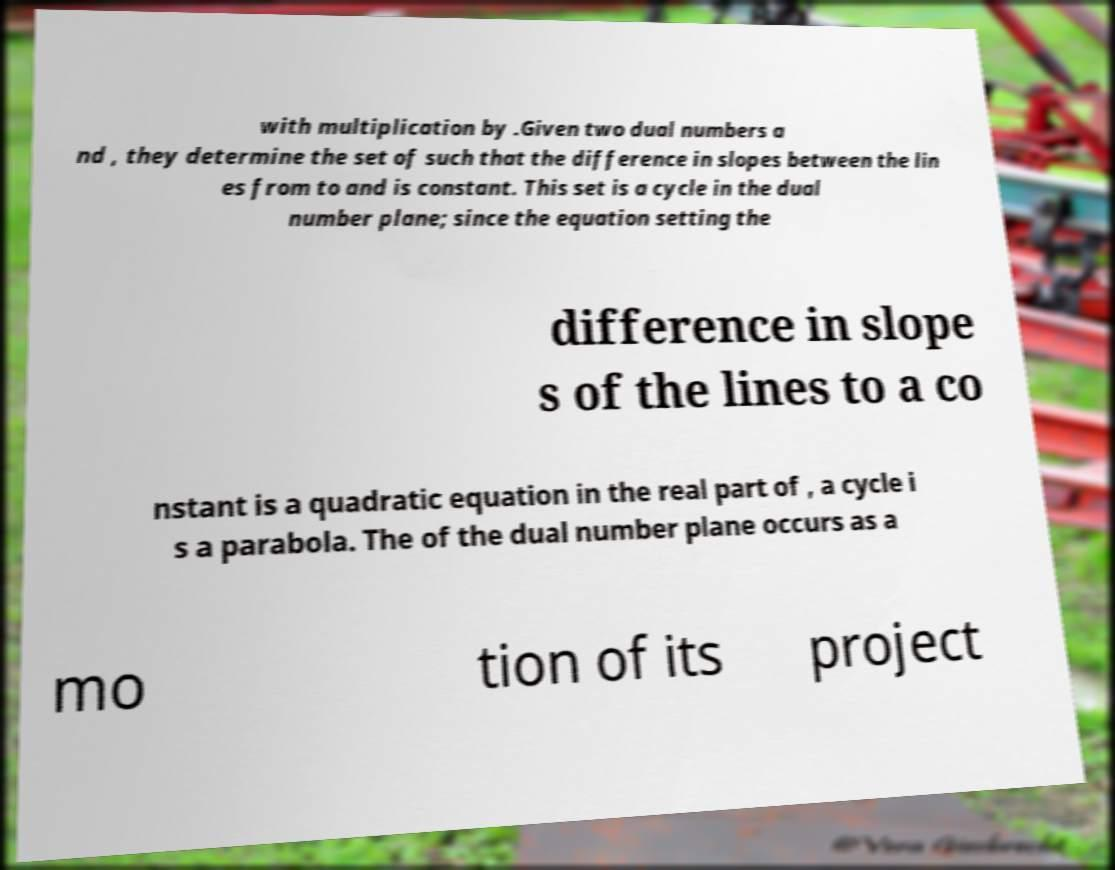I need the written content from this picture converted into text. Can you do that? with multiplication by .Given two dual numbers a nd , they determine the set of such that the difference in slopes between the lin es from to and is constant. This set is a cycle in the dual number plane; since the equation setting the difference in slope s of the lines to a co nstant is a quadratic equation in the real part of , a cycle i s a parabola. The of the dual number plane occurs as a mo tion of its project 